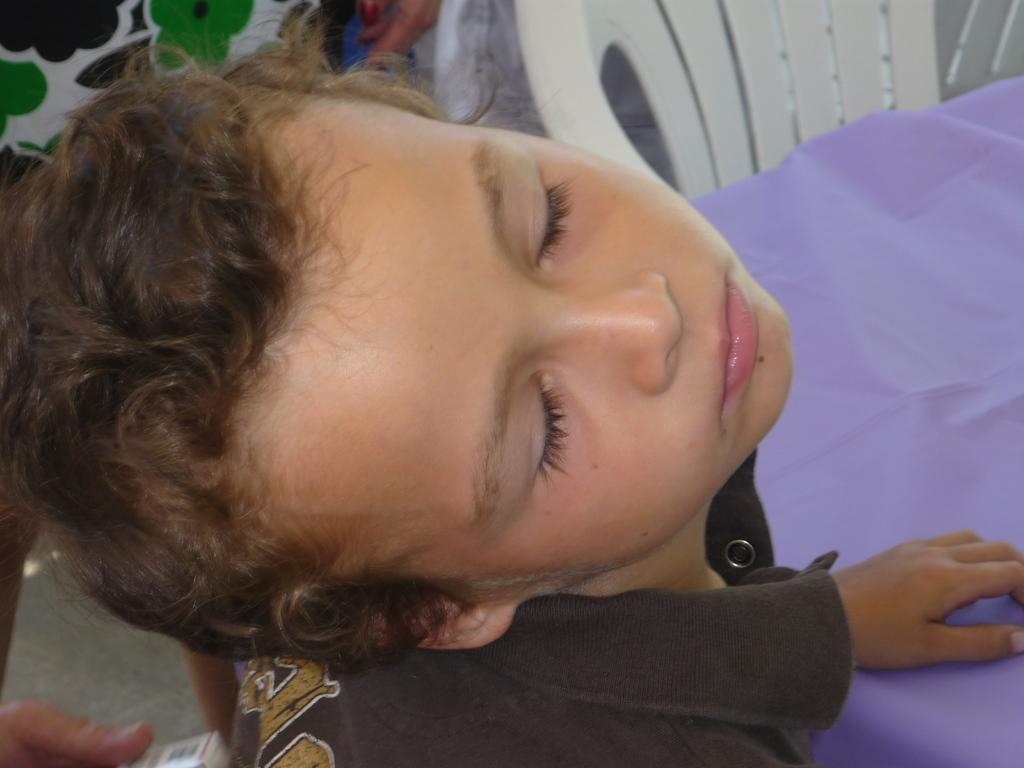Who is the main subject in the image? There is a boy in the image. What is the boy doing in the image? The boy has his eyes closed. What is the boy wearing in the image? The boy is wearing a black shirt. What furniture is present in the image? There is a chair and a table in the image. Whose hands are visible in the image? There are human hands visible on the side of the image. What type of straw is the ghost using to communicate with the boy in the image? There is no straw or ghost present in the image; it only features a boy with his eyes closed, wearing a black shirt, and sitting near a table and chair. 